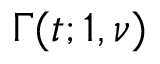<formula> <loc_0><loc_0><loc_500><loc_500>\Gamma ( t ; 1 , \nu )</formula> 